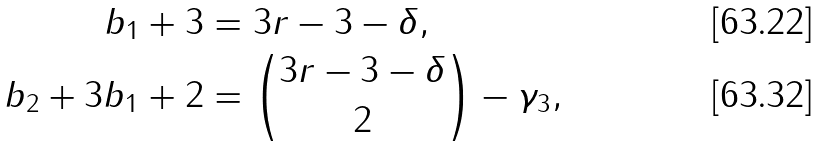<formula> <loc_0><loc_0><loc_500><loc_500>b _ { 1 } + 3 & = 3 r - 3 - \delta , \\ b _ { 2 } + 3 b _ { 1 } + 2 & = \binom { 3 r - 3 - \delta } { 2 } - \gamma _ { 3 } ,</formula> 